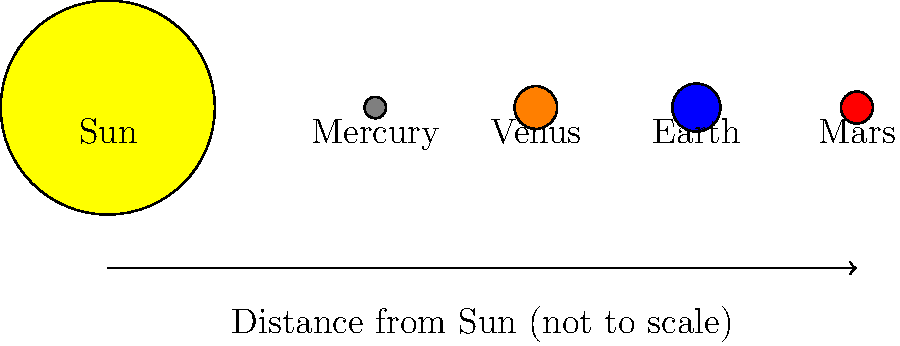Based on the diagram, which planet appears to be closest in size to Earth, and how does this relate to their actual sizes in our solar system? To answer this question, let's follow these steps:

1. Observe the relative sizes of the planets in the diagram:
   - Mercury is the smallest
   - Venus and Earth appear to be similar in size
   - Mars is slightly smaller than Venus and Earth

2. Compare the sizes visually:
   Venus appears to be the closest in size to Earth in the diagram.

3. Relate this to actual planetary sizes:
   - Earth's diameter: approximately 12,742 km
   - Venus's diameter: approximately 12,104 km
   - Mars's diameter: approximately 6,779 km
   - Mercury's diameter: approximately 4,879 km

4. Calculate the size ratios:
   - Venus/Earth: $\frac{12104}{12742} \approx 0.95$ or 95% of Earth's size
   - Mars/Earth: $\frac{6779}{12742} \approx 0.53$ or 53% of Earth's size
   - Mercury/Earth: $\frac{4879}{12742} \approx 0.38$ or 38% of Earth's size

5. Conclusion:
   The diagram accurately represents that Venus is the planet closest in size to Earth. Venus is often called Earth's "sister planet" due to their similar sizes and compositions.
Answer: Venus; accurately represents actual relative sizes. 